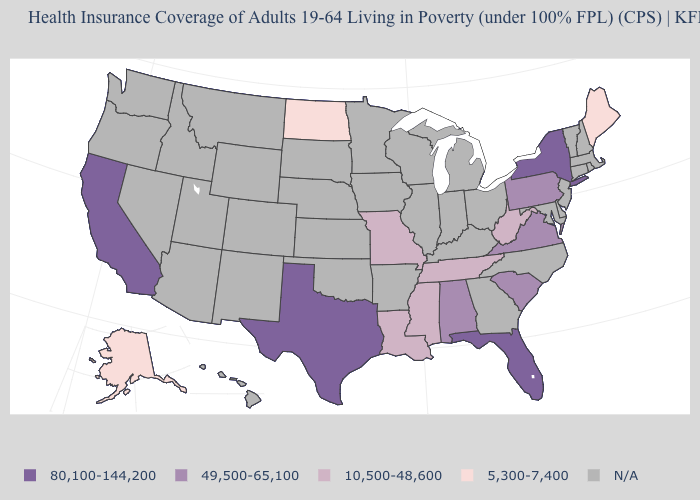What is the lowest value in the USA?
Quick response, please. 5,300-7,400. Does the first symbol in the legend represent the smallest category?
Concise answer only. No. What is the value of Connecticut?
Answer briefly. N/A. What is the value of Arizona?
Write a very short answer. N/A. Name the states that have a value in the range 10,500-48,600?
Concise answer only. Louisiana, Mississippi, Missouri, Tennessee, West Virginia. What is the value of Colorado?
Answer briefly. N/A. What is the highest value in the USA?
Give a very brief answer. 80,100-144,200. Name the states that have a value in the range 5,300-7,400?
Write a very short answer. Alaska, Maine, North Dakota. What is the lowest value in states that border Oklahoma?
Short answer required. 10,500-48,600. Name the states that have a value in the range 5,300-7,400?
Concise answer only. Alaska, Maine, North Dakota. What is the highest value in the USA?
Keep it brief. 80,100-144,200. Which states hav the highest value in the Northeast?
Write a very short answer. New York. Does North Dakota have the lowest value in the USA?
Write a very short answer. Yes. 